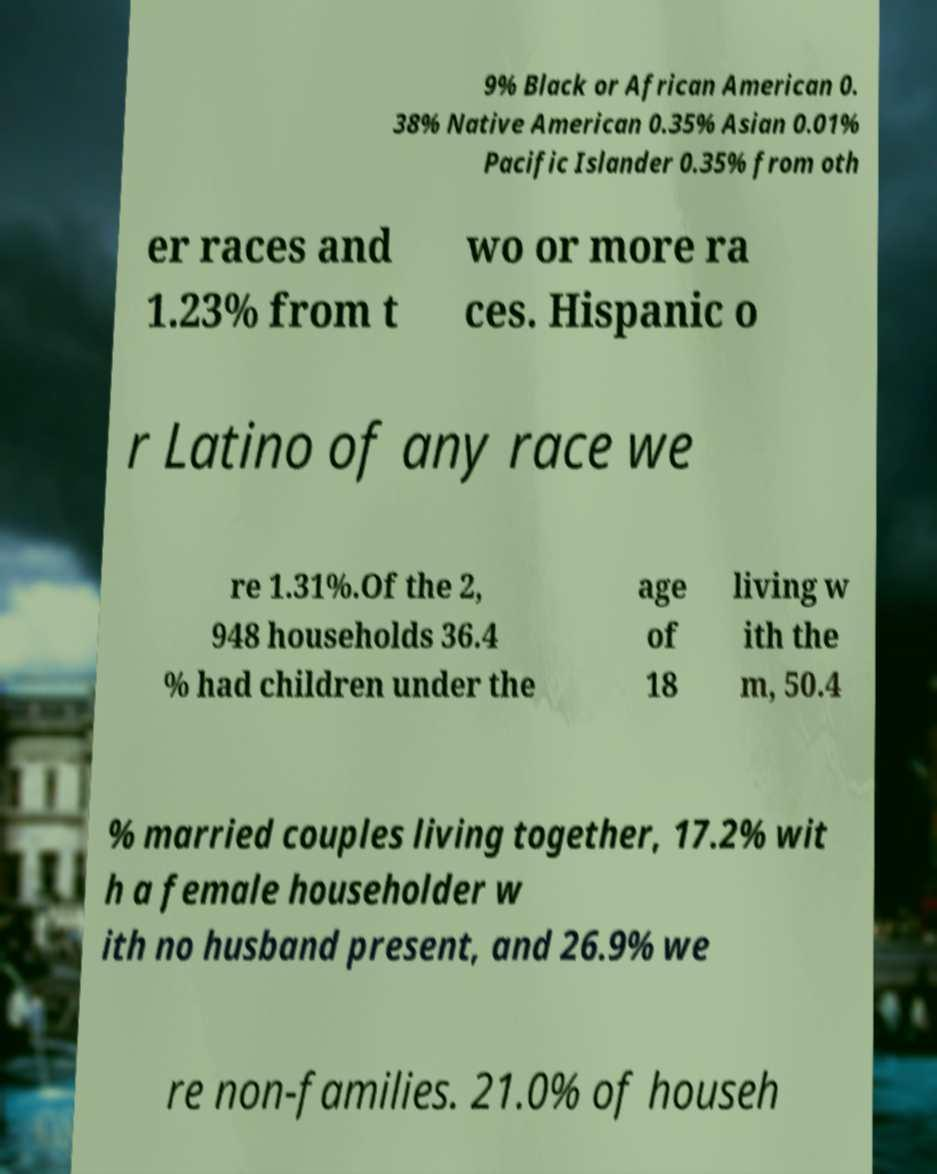Could you extract and type out the text from this image? 9% Black or African American 0. 38% Native American 0.35% Asian 0.01% Pacific Islander 0.35% from oth er races and 1.23% from t wo or more ra ces. Hispanic o r Latino of any race we re 1.31%.Of the 2, 948 households 36.4 % had children under the age of 18 living w ith the m, 50.4 % married couples living together, 17.2% wit h a female householder w ith no husband present, and 26.9% we re non-families. 21.0% of househ 